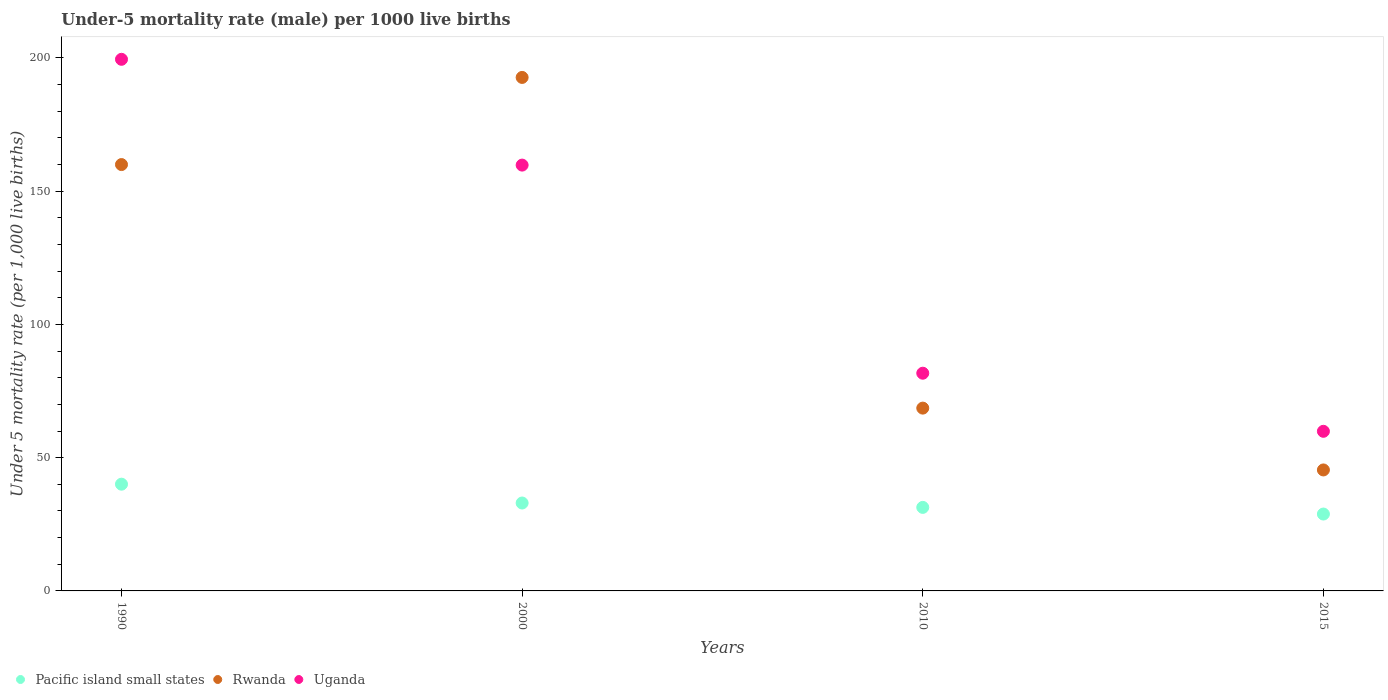What is the under-five mortality rate in Rwanda in 1990?
Ensure brevity in your answer.  160. Across all years, what is the maximum under-five mortality rate in Uganda?
Your response must be concise. 199.5. Across all years, what is the minimum under-five mortality rate in Uganda?
Make the answer very short. 59.9. In which year was the under-five mortality rate in Uganda minimum?
Provide a succinct answer. 2015. What is the total under-five mortality rate in Rwanda in the graph?
Provide a short and direct response. 466.7. What is the difference between the under-five mortality rate in Pacific island small states in 1990 and that in 2010?
Keep it short and to the point. 8.71. What is the difference between the under-five mortality rate in Uganda in 1990 and the under-five mortality rate in Pacific island small states in 2010?
Provide a short and direct response. 168.15. What is the average under-five mortality rate in Uganda per year?
Give a very brief answer. 125.22. In the year 1990, what is the difference between the under-five mortality rate in Uganda and under-five mortality rate in Rwanda?
Your answer should be compact. 39.5. In how many years, is the under-five mortality rate in Pacific island small states greater than 20?
Your response must be concise. 4. What is the ratio of the under-five mortality rate in Rwanda in 1990 to that in 2010?
Offer a very short reply. 2.33. What is the difference between the highest and the second highest under-five mortality rate in Rwanda?
Your answer should be very brief. 32.7. What is the difference between the highest and the lowest under-five mortality rate in Uganda?
Keep it short and to the point. 139.6. In how many years, is the under-five mortality rate in Pacific island small states greater than the average under-five mortality rate in Pacific island small states taken over all years?
Your answer should be compact. 1. Is the sum of the under-five mortality rate in Rwanda in 2000 and 2015 greater than the maximum under-five mortality rate in Pacific island small states across all years?
Provide a succinct answer. Yes. Does the under-five mortality rate in Rwanda monotonically increase over the years?
Make the answer very short. No. Is the under-five mortality rate in Rwanda strictly greater than the under-five mortality rate in Uganda over the years?
Ensure brevity in your answer.  No. How many dotlines are there?
Your answer should be compact. 3. How many years are there in the graph?
Make the answer very short. 4. What is the difference between two consecutive major ticks on the Y-axis?
Provide a succinct answer. 50. Does the graph contain any zero values?
Offer a very short reply. No. Does the graph contain grids?
Ensure brevity in your answer.  No. What is the title of the graph?
Your answer should be very brief. Under-5 mortality rate (male) per 1000 live births. What is the label or title of the X-axis?
Give a very brief answer. Years. What is the label or title of the Y-axis?
Offer a very short reply. Under 5 mortality rate (per 1,0 live births). What is the Under 5 mortality rate (per 1,000 live births) of Pacific island small states in 1990?
Your answer should be compact. 40.06. What is the Under 5 mortality rate (per 1,000 live births) in Rwanda in 1990?
Make the answer very short. 160. What is the Under 5 mortality rate (per 1,000 live births) of Uganda in 1990?
Your answer should be compact. 199.5. What is the Under 5 mortality rate (per 1,000 live births) in Pacific island small states in 2000?
Give a very brief answer. 32.99. What is the Under 5 mortality rate (per 1,000 live births) of Rwanda in 2000?
Offer a very short reply. 192.7. What is the Under 5 mortality rate (per 1,000 live births) of Uganda in 2000?
Your answer should be very brief. 159.8. What is the Under 5 mortality rate (per 1,000 live births) in Pacific island small states in 2010?
Offer a very short reply. 31.35. What is the Under 5 mortality rate (per 1,000 live births) in Rwanda in 2010?
Your answer should be compact. 68.6. What is the Under 5 mortality rate (per 1,000 live births) of Uganda in 2010?
Keep it short and to the point. 81.7. What is the Under 5 mortality rate (per 1,000 live births) of Pacific island small states in 2015?
Provide a short and direct response. 28.85. What is the Under 5 mortality rate (per 1,000 live births) in Rwanda in 2015?
Your response must be concise. 45.4. What is the Under 5 mortality rate (per 1,000 live births) of Uganda in 2015?
Keep it short and to the point. 59.9. Across all years, what is the maximum Under 5 mortality rate (per 1,000 live births) in Pacific island small states?
Keep it short and to the point. 40.06. Across all years, what is the maximum Under 5 mortality rate (per 1,000 live births) of Rwanda?
Keep it short and to the point. 192.7. Across all years, what is the maximum Under 5 mortality rate (per 1,000 live births) of Uganda?
Keep it short and to the point. 199.5. Across all years, what is the minimum Under 5 mortality rate (per 1,000 live births) in Pacific island small states?
Your answer should be compact. 28.85. Across all years, what is the minimum Under 5 mortality rate (per 1,000 live births) in Rwanda?
Your answer should be compact. 45.4. Across all years, what is the minimum Under 5 mortality rate (per 1,000 live births) of Uganda?
Provide a short and direct response. 59.9. What is the total Under 5 mortality rate (per 1,000 live births) of Pacific island small states in the graph?
Your answer should be compact. 133.25. What is the total Under 5 mortality rate (per 1,000 live births) in Rwanda in the graph?
Your answer should be very brief. 466.7. What is the total Under 5 mortality rate (per 1,000 live births) in Uganda in the graph?
Keep it short and to the point. 500.9. What is the difference between the Under 5 mortality rate (per 1,000 live births) of Pacific island small states in 1990 and that in 2000?
Give a very brief answer. 7.07. What is the difference between the Under 5 mortality rate (per 1,000 live births) in Rwanda in 1990 and that in 2000?
Your answer should be compact. -32.7. What is the difference between the Under 5 mortality rate (per 1,000 live births) of Uganda in 1990 and that in 2000?
Offer a terse response. 39.7. What is the difference between the Under 5 mortality rate (per 1,000 live births) of Pacific island small states in 1990 and that in 2010?
Ensure brevity in your answer.  8.71. What is the difference between the Under 5 mortality rate (per 1,000 live births) of Rwanda in 1990 and that in 2010?
Offer a terse response. 91.4. What is the difference between the Under 5 mortality rate (per 1,000 live births) of Uganda in 1990 and that in 2010?
Make the answer very short. 117.8. What is the difference between the Under 5 mortality rate (per 1,000 live births) of Pacific island small states in 1990 and that in 2015?
Provide a short and direct response. 11.21. What is the difference between the Under 5 mortality rate (per 1,000 live births) of Rwanda in 1990 and that in 2015?
Keep it short and to the point. 114.6. What is the difference between the Under 5 mortality rate (per 1,000 live births) in Uganda in 1990 and that in 2015?
Offer a very short reply. 139.6. What is the difference between the Under 5 mortality rate (per 1,000 live births) of Pacific island small states in 2000 and that in 2010?
Keep it short and to the point. 1.64. What is the difference between the Under 5 mortality rate (per 1,000 live births) in Rwanda in 2000 and that in 2010?
Make the answer very short. 124.1. What is the difference between the Under 5 mortality rate (per 1,000 live births) of Uganda in 2000 and that in 2010?
Ensure brevity in your answer.  78.1. What is the difference between the Under 5 mortality rate (per 1,000 live births) of Pacific island small states in 2000 and that in 2015?
Your answer should be very brief. 4.14. What is the difference between the Under 5 mortality rate (per 1,000 live births) in Rwanda in 2000 and that in 2015?
Give a very brief answer. 147.3. What is the difference between the Under 5 mortality rate (per 1,000 live births) of Uganda in 2000 and that in 2015?
Provide a succinct answer. 99.9. What is the difference between the Under 5 mortality rate (per 1,000 live births) in Pacific island small states in 2010 and that in 2015?
Provide a short and direct response. 2.5. What is the difference between the Under 5 mortality rate (per 1,000 live births) in Rwanda in 2010 and that in 2015?
Your response must be concise. 23.2. What is the difference between the Under 5 mortality rate (per 1,000 live births) of Uganda in 2010 and that in 2015?
Provide a short and direct response. 21.8. What is the difference between the Under 5 mortality rate (per 1,000 live births) in Pacific island small states in 1990 and the Under 5 mortality rate (per 1,000 live births) in Rwanda in 2000?
Your answer should be compact. -152.64. What is the difference between the Under 5 mortality rate (per 1,000 live births) in Pacific island small states in 1990 and the Under 5 mortality rate (per 1,000 live births) in Uganda in 2000?
Provide a short and direct response. -119.74. What is the difference between the Under 5 mortality rate (per 1,000 live births) in Pacific island small states in 1990 and the Under 5 mortality rate (per 1,000 live births) in Rwanda in 2010?
Provide a succinct answer. -28.54. What is the difference between the Under 5 mortality rate (per 1,000 live births) in Pacific island small states in 1990 and the Under 5 mortality rate (per 1,000 live births) in Uganda in 2010?
Ensure brevity in your answer.  -41.64. What is the difference between the Under 5 mortality rate (per 1,000 live births) of Rwanda in 1990 and the Under 5 mortality rate (per 1,000 live births) of Uganda in 2010?
Make the answer very short. 78.3. What is the difference between the Under 5 mortality rate (per 1,000 live births) of Pacific island small states in 1990 and the Under 5 mortality rate (per 1,000 live births) of Rwanda in 2015?
Provide a short and direct response. -5.34. What is the difference between the Under 5 mortality rate (per 1,000 live births) of Pacific island small states in 1990 and the Under 5 mortality rate (per 1,000 live births) of Uganda in 2015?
Offer a very short reply. -19.84. What is the difference between the Under 5 mortality rate (per 1,000 live births) of Rwanda in 1990 and the Under 5 mortality rate (per 1,000 live births) of Uganda in 2015?
Provide a short and direct response. 100.1. What is the difference between the Under 5 mortality rate (per 1,000 live births) in Pacific island small states in 2000 and the Under 5 mortality rate (per 1,000 live births) in Rwanda in 2010?
Provide a succinct answer. -35.61. What is the difference between the Under 5 mortality rate (per 1,000 live births) of Pacific island small states in 2000 and the Under 5 mortality rate (per 1,000 live births) of Uganda in 2010?
Keep it short and to the point. -48.71. What is the difference between the Under 5 mortality rate (per 1,000 live births) in Rwanda in 2000 and the Under 5 mortality rate (per 1,000 live births) in Uganda in 2010?
Ensure brevity in your answer.  111. What is the difference between the Under 5 mortality rate (per 1,000 live births) in Pacific island small states in 2000 and the Under 5 mortality rate (per 1,000 live births) in Rwanda in 2015?
Keep it short and to the point. -12.41. What is the difference between the Under 5 mortality rate (per 1,000 live births) in Pacific island small states in 2000 and the Under 5 mortality rate (per 1,000 live births) in Uganda in 2015?
Ensure brevity in your answer.  -26.91. What is the difference between the Under 5 mortality rate (per 1,000 live births) in Rwanda in 2000 and the Under 5 mortality rate (per 1,000 live births) in Uganda in 2015?
Offer a very short reply. 132.8. What is the difference between the Under 5 mortality rate (per 1,000 live births) in Pacific island small states in 2010 and the Under 5 mortality rate (per 1,000 live births) in Rwanda in 2015?
Give a very brief answer. -14.05. What is the difference between the Under 5 mortality rate (per 1,000 live births) in Pacific island small states in 2010 and the Under 5 mortality rate (per 1,000 live births) in Uganda in 2015?
Ensure brevity in your answer.  -28.55. What is the difference between the Under 5 mortality rate (per 1,000 live births) of Rwanda in 2010 and the Under 5 mortality rate (per 1,000 live births) of Uganda in 2015?
Ensure brevity in your answer.  8.7. What is the average Under 5 mortality rate (per 1,000 live births) of Pacific island small states per year?
Keep it short and to the point. 33.31. What is the average Under 5 mortality rate (per 1,000 live births) in Rwanda per year?
Give a very brief answer. 116.67. What is the average Under 5 mortality rate (per 1,000 live births) of Uganda per year?
Your response must be concise. 125.22. In the year 1990, what is the difference between the Under 5 mortality rate (per 1,000 live births) in Pacific island small states and Under 5 mortality rate (per 1,000 live births) in Rwanda?
Offer a very short reply. -119.94. In the year 1990, what is the difference between the Under 5 mortality rate (per 1,000 live births) of Pacific island small states and Under 5 mortality rate (per 1,000 live births) of Uganda?
Your answer should be compact. -159.44. In the year 1990, what is the difference between the Under 5 mortality rate (per 1,000 live births) in Rwanda and Under 5 mortality rate (per 1,000 live births) in Uganda?
Make the answer very short. -39.5. In the year 2000, what is the difference between the Under 5 mortality rate (per 1,000 live births) in Pacific island small states and Under 5 mortality rate (per 1,000 live births) in Rwanda?
Your response must be concise. -159.71. In the year 2000, what is the difference between the Under 5 mortality rate (per 1,000 live births) in Pacific island small states and Under 5 mortality rate (per 1,000 live births) in Uganda?
Your answer should be very brief. -126.81. In the year 2000, what is the difference between the Under 5 mortality rate (per 1,000 live births) in Rwanda and Under 5 mortality rate (per 1,000 live births) in Uganda?
Provide a succinct answer. 32.9. In the year 2010, what is the difference between the Under 5 mortality rate (per 1,000 live births) of Pacific island small states and Under 5 mortality rate (per 1,000 live births) of Rwanda?
Provide a succinct answer. -37.25. In the year 2010, what is the difference between the Under 5 mortality rate (per 1,000 live births) of Pacific island small states and Under 5 mortality rate (per 1,000 live births) of Uganda?
Offer a terse response. -50.35. In the year 2010, what is the difference between the Under 5 mortality rate (per 1,000 live births) in Rwanda and Under 5 mortality rate (per 1,000 live births) in Uganda?
Provide a short and direct response. -13.1. In the year 2015, what is the difference between the Under 5 mortality rate (per 1,000 live births) in Pacific island small states and Under 5 mortality rate (per 1,000 live births) in Rwanda?
Your answer should be compact. -16.55. In the year 2015, what is the difference between the Under 5 mortality rate (per 1,000 live births) of Pacific island small states and Under 5 mortality rate (per 1,000 live births) of Uganda?
Offer a terse response. -31.05. In the year 2015, what is the difference between the Under 5 mortality rate (per 1,000 live births) in Rwanda and Under 5 mortality rate (per 1,000 live births) in Uganda?
Provide a succinct answer. -14.5. What is the ratio of the Under 5 mortality rate (per 1,000 live births) in Pacific island small states in 1990 to that in 2000?
Your response must be concise. 1.21. What is the ratio of the Under 5 mortality rate (per 1,000 live births) of Rwanda in 1990 to that in 2000?
Give a very brief answer. 0.83. What is the ratio of the Under 5 mortality rate (per 1,000 live births) of Uganda in 1990 to that in 2000?
Your answer should be compact. 1.25. What is the ratio of the Under 5 mortality rate (per 1,000 live births) in Pacific island small states in 1990 to that in 2010?
Your response must be concise. 1.28. What is the ratio of the Under 5 mortality rate (per 1,000 live births) in Rwanda in 1990 to that in 2010?
Offer a very short reply. 2.33. What is the ratio of the Under 5 mortality rate (per 1,000 live births) in Uganda in 1990 to that in 2010?
Offer a terse response. 2.44. What is the ratio of the Under 5 mortality rate (per 1,000 live births) in Pacific island small states in 1990 to that in 2015?
Ensure brevity in your answer.  1.39. What is the ratio of the Under 5 mortality rate (per 1,000 live births) of Rwanda in 1990 to that in 2015?
Provide a short and direct response. 3.52. What is the ratio of the Under 5 mortality rate (per 1,000 live births) of Uganda in 1990 to that in 2015?
Make the answer very short. 3.33. What is the ratio of the Under 5 mortality rate (per 1,000 live births) of Pacific island small states in 2000 to that in 2010?
Offer a terse response. 1.05. What is the ratio of the Under 5 mortality rate (per 1,000 live births) of Rwanda in 2000 to that in 2010?
Make the answer very short. 2.81. What is the ratio of the Under 5 mortality rate (per 1,000 live births) in Uganda in 2000 to that in 2010?
Provide a succinct answer. 1.96. What is the ratio of the Under 5 mortality rate (per 1,000 live births) in Pacific island small states in 2000 to that in 2015?
Offer a terse response. 1.14. What is the ratio of the Under 5 mortality rate (per 1,000 live births) of Rwanda in 2000 to that in 2015?
Your answer should be very brief. 4.24. What is the ratio of the Under 5 mortality rate (per 1,000 live births) of Uganda in 2000 to that in 2015?
Your answer should be compact. 2.67. What is the ratio of the Under 5 mortality rate (per 1,000 live births) of Pacific island small states in 2010 to that in 2015?
Give a very brief answer. 1.09. What is the ratio of the Under 5 mortality rate (per 1,000 live births) of Rwanda in 2010 to that in 2015?
Provide a short and direct response. 1.51. What is the ratio of the Under 5 mortality rate (per 1,000 live births) of Uganda in 2010 to that in 2015?
Keep it short and to the point. 1.36. What is the difference between the highest and the second highest Under 5 mortality rate (per 1,000 live births) in Pacific island small states?
Your response must be concise. 7.07. What is the difference between the highest and the second highest Under 5 mortality rate (per 1,000 live births) in Rwanda?
Ensure brevity in your answer.  32.7. What is the difference between the highest and the second highest Under 5 mortality rate (per 1,000 live births) of Uganda?
Offer a very short reply. 39.7. What is the difference between the highest and the lowest Under 5 mortality rate (per 1,000 live births) in Pacific island small states?
Provide a short and direct response. 11.21. What is the difference between the highest and the lowest Under 5 mortality rate (per 1,000 live births) in Rwanda?
Offer a very short reply. 147.3. What is the difference between the highest and the lowest Under 5 mortality rate (per 1,000 live births) in Uganda?
Your answer should be compact. 139.6. 